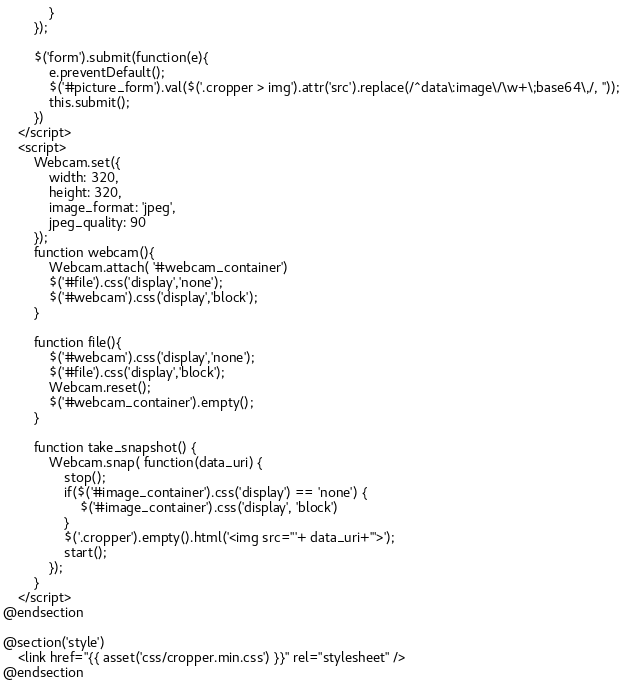<code> <loc_0><loc_0><loc_500><loc_500><_PHP_>            }
        });

        $('form').submit(function(e){
            e.preventDefault();
            $('#picture_form').val($('.cropper > img').attr('src').replace(/^data\:image\/\w+\;base64\,/, ''));
            this.submit();
        })
    </script>
    <script>
        Webcam.set({
            width: 320,
            height: 320,
            image_format: 'jpeg',
            jpeg_quality: 90
        });
        function webcam(){
            Webcam.attach( '#webcam_container')
            $('#file').css('display','none');
            $('#webcam').css('display','block');
        }

        function file(){
            $('#webcam').css('display','none');
            $('#file').css('display','block');
            Webcam.reset();
            $('#webcam_container').empty();
        }

        function take_snapshot() {
            Webcam.snap( function(data_uri) {
                stop();
                if($('#image_container').css('display') == 'none') {
                    $('#image_container').css('display', 'block')
                }
                $('.cropper').empty().html('<img src="'+ data_uri+'">');
                start();
            });
        }
    </script>
@endsection

@section('style')
    <link href="{{ asset('css/cropper.min.css') }}" rel="stylesheet" />
@endsection</code> 